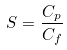Convert formula to latex. <formula><loc_0><loc_0><loc_500><loc_500>S = \frac { C _ { p } } { C _ { f } }</formula> 